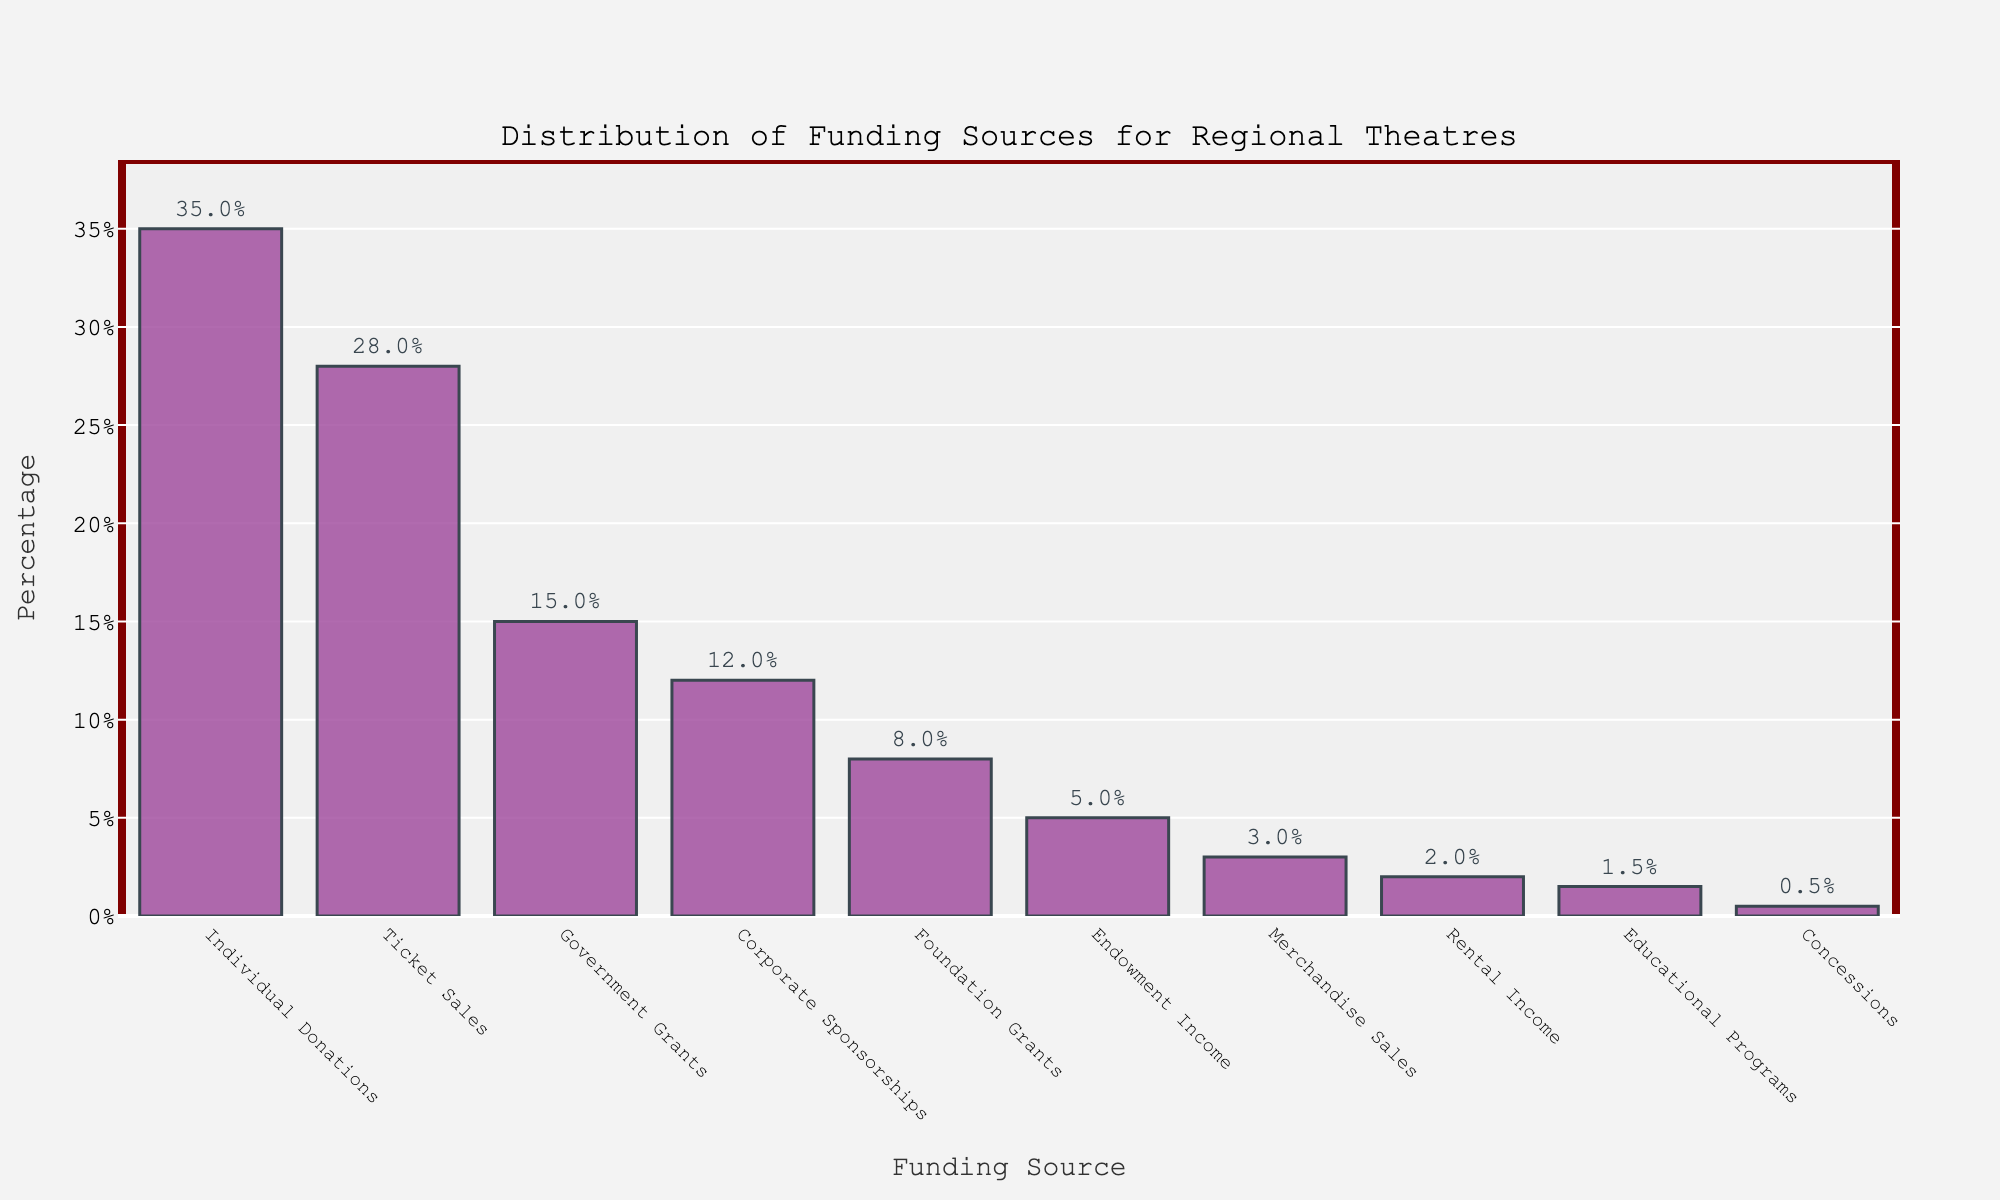What's the most significant funding source for regional theatres in the US? The tallest bar represents the highest percentage. The "Individual Donations" bar is the tallest, indicating it is the most significant funding source at 35%.
Answer: Individual Donations How much higher is the percentage of funding from Individual Donations compared to Corporate Sponsorships? The percentage for Individual Donations is 35%, and for Corporate Sponsorships, it is 12%. The difference is calculated as 35% - 12% = 23%.
Answer: 23% What percentage of funding comes from Ticket Sales and Government Grants combined? The percentage from Ticket Sales is 28%, and from Government Grants is 15%. Combining these, 28% + 15% = 43%.
Answer: 43% Which funding source contributes the least to regional theatres? The shortest bar indicates the lowest percentage. The "Concessions" bar is the shortest at 0.5%, making it the least contributing source.
Answer: Concessions How do Government Grants and Foundation Grants compare in terms of funding percentage? The bar for Government Grants indicates a 15% contribution, while Foundation Grants show 8%. Government Grants contribute more than Foundation Grants.
Answer: Government Grants contribute more than Foundation Grants What visual representation is used to show the percentage value of each funding source? The percentage values are displayed at the top of each bar in the form of labels, ensuring clear visibility.
Answer: Labels above each bar How does the rental income compare with endowment income as a funding source? The bar for Rental Income indicates 2%, while the bar for Endowment Income indicates 5%. Endowment Income provides a higher percentage of funds compared to Rental Income.
Answer: Endowment Income provides more than Rental Income What percentage of funding comes from sources contributing less than 10% individually? Calculating percentages from sources contributing less than 10%: Foundation Grants (8%), Endowment Income (5%), Merchandise Sales (3%), Rental Income (2%), Educational Programs (1.5%), Concessions (0.5%). Summing these: 8% + 5% + 3% + 2% + 1.5% + 0.5% = 20%.
Answer: 20% Which three funding sources contribute the most to regional theatres? By examining the three tallest bars, the funding sources with the highest percentages are Individual Donations (35%), Ticket Sales (28%), and Government Grants (15%).
Answer: Individual Donations, Ticket Sales, Government Grants What's the average percentage contribution from Ticket Sales, Corporate Sponsorships, and Educational Programs? Calculating the average: (28% Ticket Sales + 12% Corporate Sponsorships + 1.5% Educational Programs) / 3 = 41.5% / 3 = approximately 13.83%.
Answer: 13.83% 